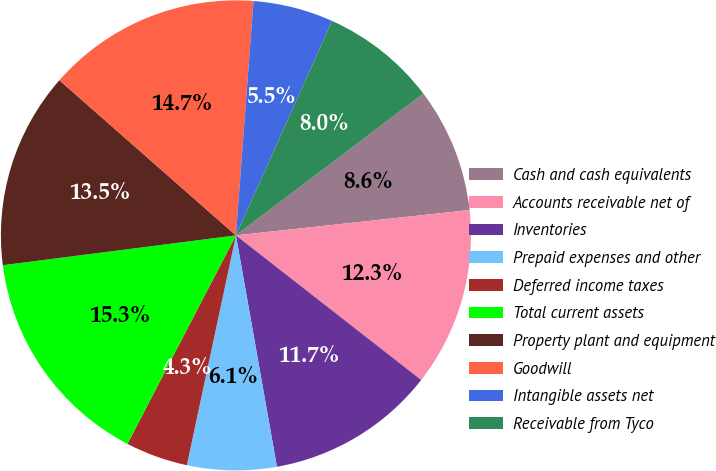Convert chart. <chart><loc_0><loc_0><loc_500><loc_500><pie_chart><fcel>Cash and cash equivalents<fcel>Accounts receivable net of<fcel>Inventories<fcel>Prepaid expenses and other<fcel>Deferred income taxes<fcel>Total current assets<fcel>Property plant and equipment<fcel>Goodwill<fcel>Intangible assets net<fcel>Receivable from Tyco<nl><fcel>8.59%<fcel>12.27%<fcel>11.66%<fcel>6.14%<fcel>4.29%<fcel>15.34%<fcel>13.5%<fcel>14.72%<fcel>5.52%<fcel>7.98%<nl></chart> 